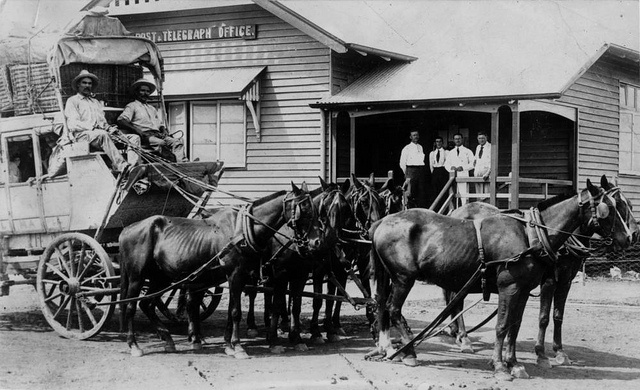Describe the objects in this image and their specific colors. I can see horse in lightgray, black, gray, and darkgray tones, horse in lightgray, black, gray, and darkgray tones, horse in lightgray, black, darkgray, and gray tones, people in lightgray, darkgray, black, and gray tones, and people in lightgray, black, darkgray, and gray tones in this image. 